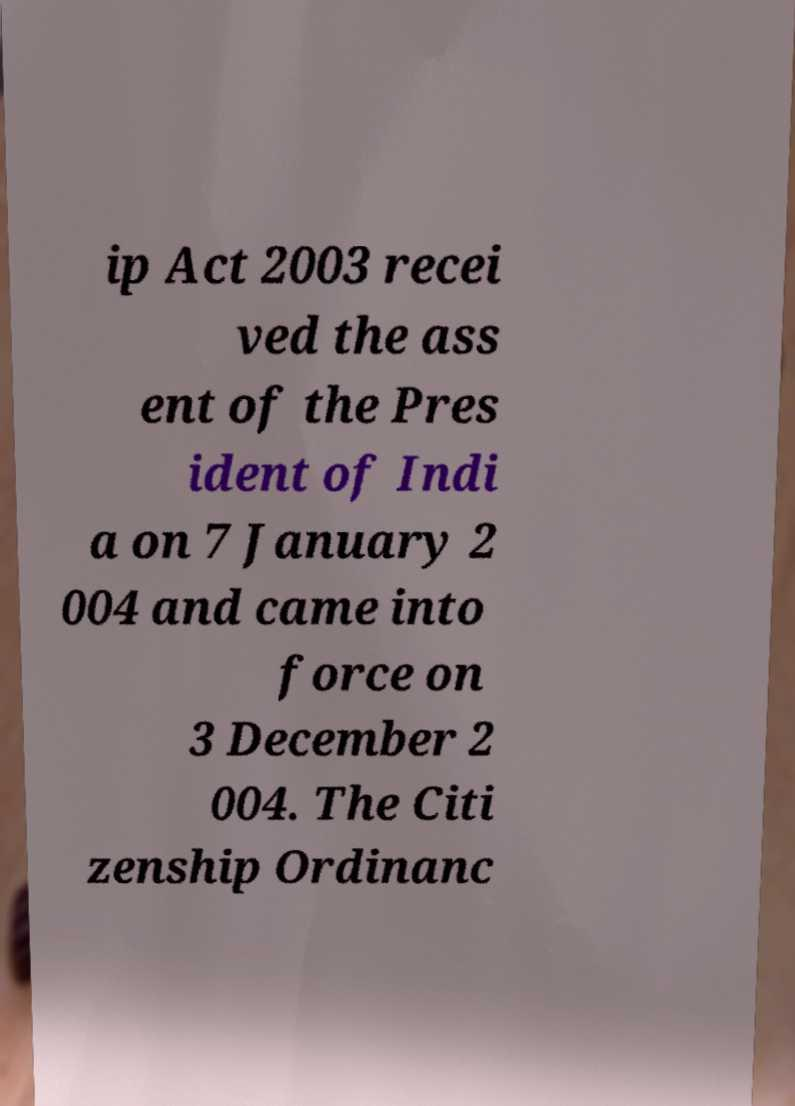Can you read and provide the text displayed in the image?This photo seems to have some interesting text. Can you extract and type it out for me? ip Act 2003 recei ved the ass ent of the Pres ident of Indi a on 7 January 2 004 and came into force on 3 December 2 004. The Citi zenship Ordinanc 